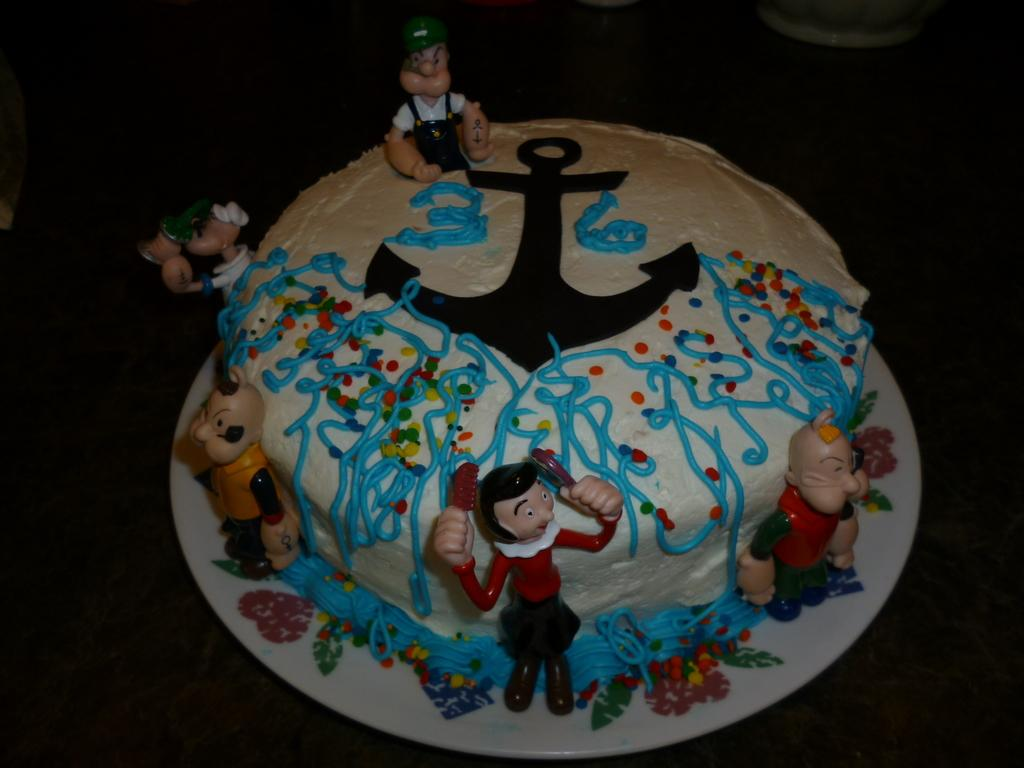Where was the image taken? The image was taken indoors. What piece of furniture is present in the image? There is a table in the image. What is placed on the table? There is a plate on the table. What is on the plate? There is a cake with cream on the plate, and there are a few toys on the plate as well. Reasoning: Let' Let's think step by step in order to produce the conversation. We start by identifying the setting of the image, which is indoors. Then, we describe the main object in the image, which is a table. Next, we focus on the plate that is on the table and the items on the plate, which include a cake with cream and a few toys. Each question is designed to elicit a specific detail about the image that is known from the provided facts. Absurd Question/Answer: What type of apple is on the table in the image? There is no apple present in the image; it features a cake with cream and toys on a plate. Can you see a receipt for the cake on the table in the image? There is no receipt visible in the image. 